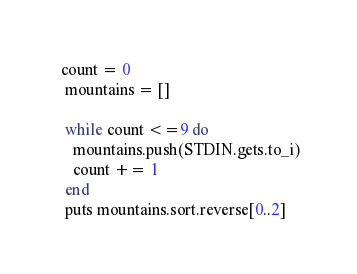Convert code to text. <code><loc_0><loc_0><loc_500><loc_500><_Ruby_> count = 0
  mountains = []

  while count <=9 do
    mountains.push(STDIN.gets.to_i)
    count += 1
  end
  puts mountains.sort.reverse[0..2]</code> 